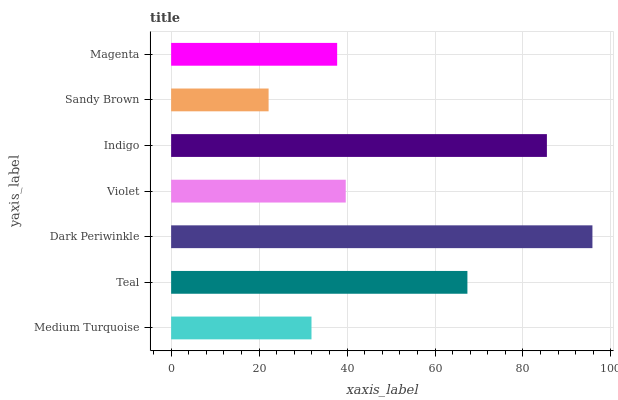Is Sandy Brown the minimum?
Answer yes or no. Yes. Is Dark Periwinkle the maximum?
Answer yes or no. Yes. Is Teal the minimum?
Answer yes or no. No. Is Teal the maximum?
Answer yes or no. No. Is Teal greater than Medium Turquoise?
Answer yes or no. Yes. Is Medium Turquoise less than Teal?
Answer yes or no. Yes. Is Medium Turquoise greater than Teal?
Answer yes or no. No. Is Teal less than Medium Turquoise?
Answer yes or no. No. Is Violet the high median?
Answer yes or no. Yes. Is Violet the low median?
Answer yes or no. Yes. Is Medium Turquoise the high median?
Answer yes or no. No. Is Dark Periwinkle the low median?
Answer yes or no. No. 